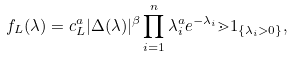Convert formula to latex. <formula><loc_0><loc_0><loc_500><loc_500>f _ { L } ( \lambda ) = c _ { L } ^ { a } | \Delta ( \lambda ) | ^ { \beta } \prod _ { i = 1 } ^ { n } \lambda _ { i } ^ { a } e ^ { - \lambda _ { i } } \mathbb { m } { 1 } _ { \{ \lambda _ { i } > 0 \} } ,</formula> 